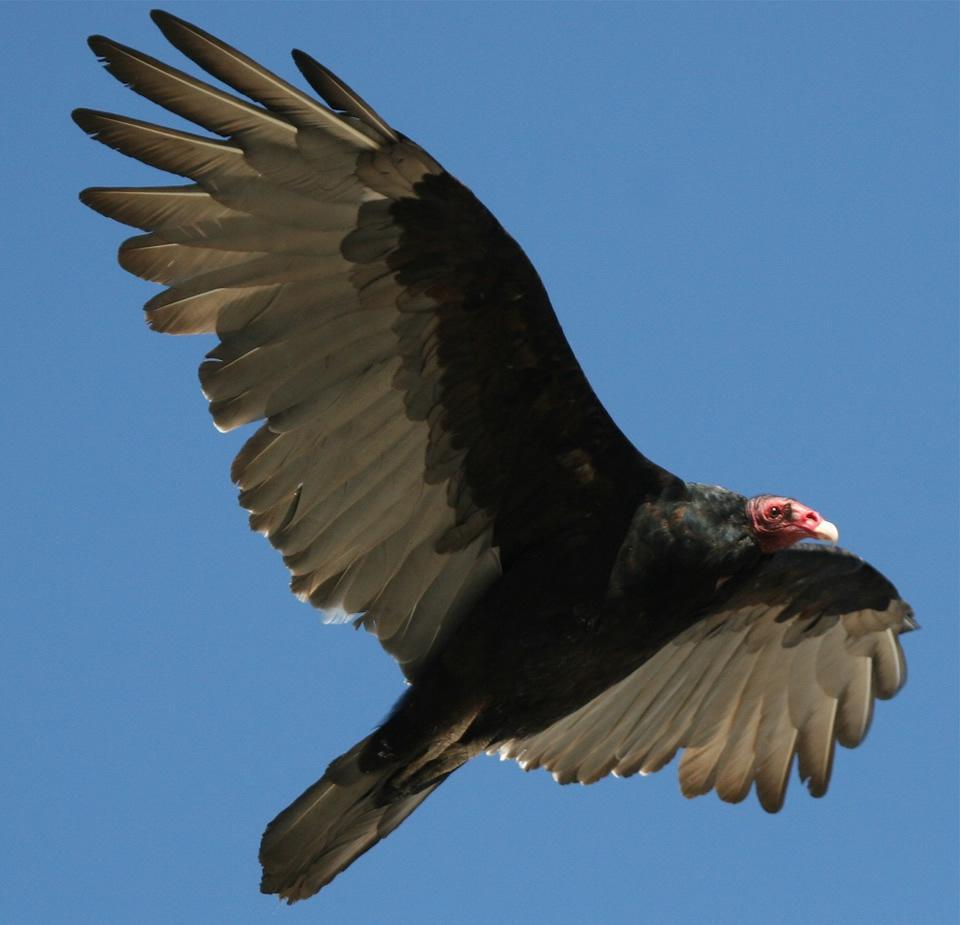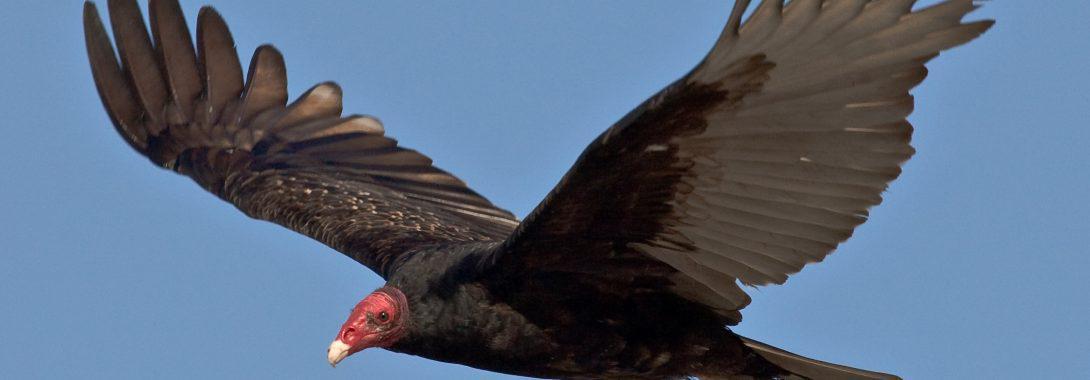The first image is the image on the left, the second image is the image on the right. Evaluate the accuracy of this statement regarding the images: "the bird on the left image is facing right.". Is it true? Answer yes or no. Yes. 